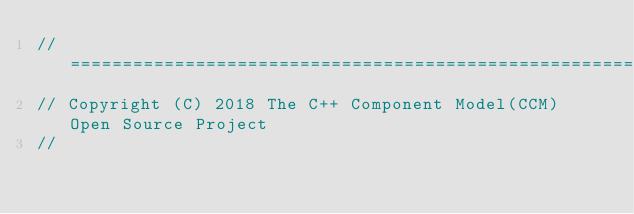<code> <loc_0><loc_0><loc_500><loc_500><_C_>//=========================================================================
// Copyright (C) 2018 The C++ Component Model(CCM) Open Source Project
//</code> 